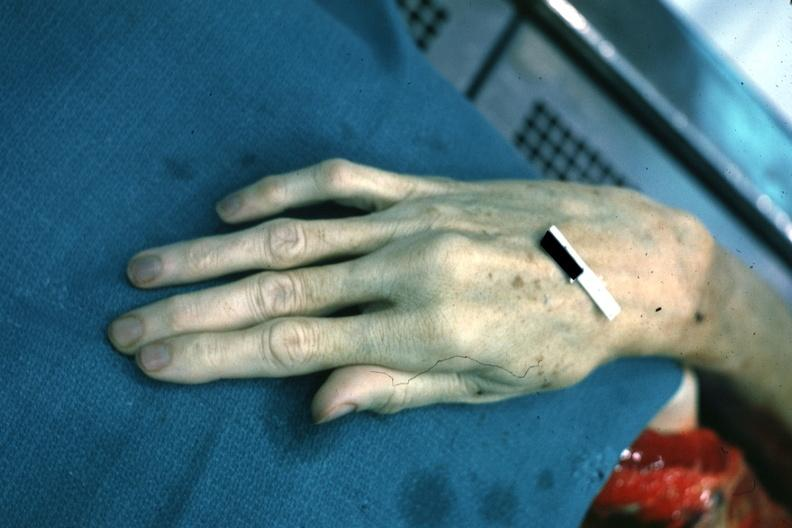what does this image show?
Answer the question using a single word or phrase. Dead typical very long fingers 